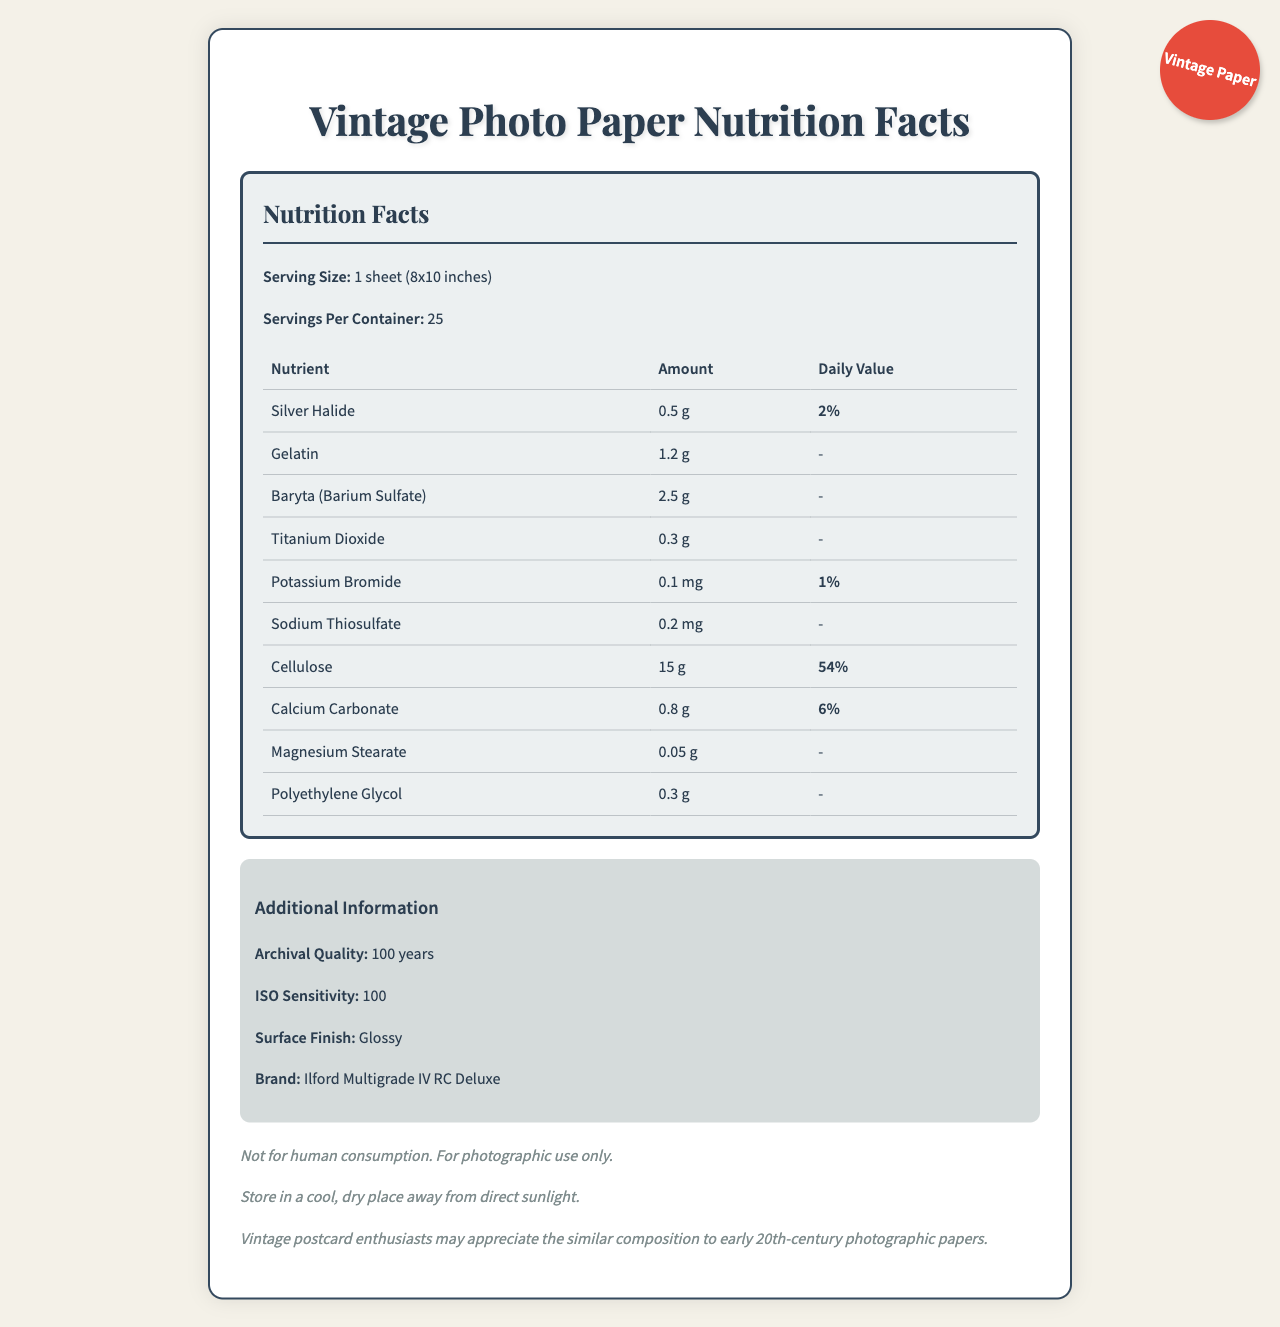what is the serving size? The serving size is listed at the beginning of the nutrition facts section as "Serving Size: 1 sheet (8x10 inches)".
Answer: 1 sheet (8x10 inches) how many servings per container are there? The document states "Servings Per Container: 25" right after the serving size information.
Answer: 25 What is the amount of Gelatin present per serving? From the nutritional facts table, Gelatin is listed with an amount of 1.2 grams per serving.
Answer: 1.2 g What is the daily value percentage of Silver Halide? The daily value percentage of Silver Halide, according to the nutritional facts table, is 2%.
Answer: 2% what is the archival quality duration of this photo paper? In the additional information section, the document states the archival quality as "100 years".
Answer: 100 years Which of the following nutrients has the highest daily value percentage based on the document? A. Silver Halide B. Potassium Bromide C. Cellulose D. Calcium Carbonate The daily value percentages listed are: Silver Halide - 2%, Potassium Bromide - 1%, Cellulose - 54%, and Calcium Carbonate - 6%. Therefore, Cellulose has the highest daily value percentage.
Answer: C. Cellulose What is the unit of measurement for Potassium Bromide? A. grams B. milligrams C. micrograms The document lists Potassium Bromide with an amount of 0.1 mg, indicating milligrams as the unit.
Answer: B. milligrams Is the document providing any information about the ISO sensitivity of the photographic paper? The additional information section mentions "ISO Sensitivity: 100".
Answer: Yes Summarize the main idea of the document. The document is designed like a nutrition label but for vintage photographic paper, highlighting its compositions, measurements, and important usage notes.
Answer: The document provides a detailed "Nutrition Facts" label for vintage photographic paper, listing various components such as Silver Halide, Gelatin, and Cellulose, along with their amounts and daily values. It also includes additional information like archival quality, ISO sensitivity, and surface finish, and it comes with disclaimers about its use. What is the brand of the photographic paper mentioned in the document? As stated in the additional information section, the brand of the paper is "Ilford Multigrade IV RC Deluxe".
Answer: Ilford Multigrade IV RC Deluxe How much Sodium Thiosulfate is present per serving? The nutritional facts table lists Sodium Thiosulfate with an amount of 0.2 mg per serving.
Answer: 0.2 mg What is the surface finish of the photographic paper? The additional information section mentions "Surface Finish: Glossy".
Answer: Glossy What is the purpose of the calcium carbonate in the photographic paper? The document does not state the specific purpose of the Calcium Carbonate in the photographic paper.
Answer: Not enough information 